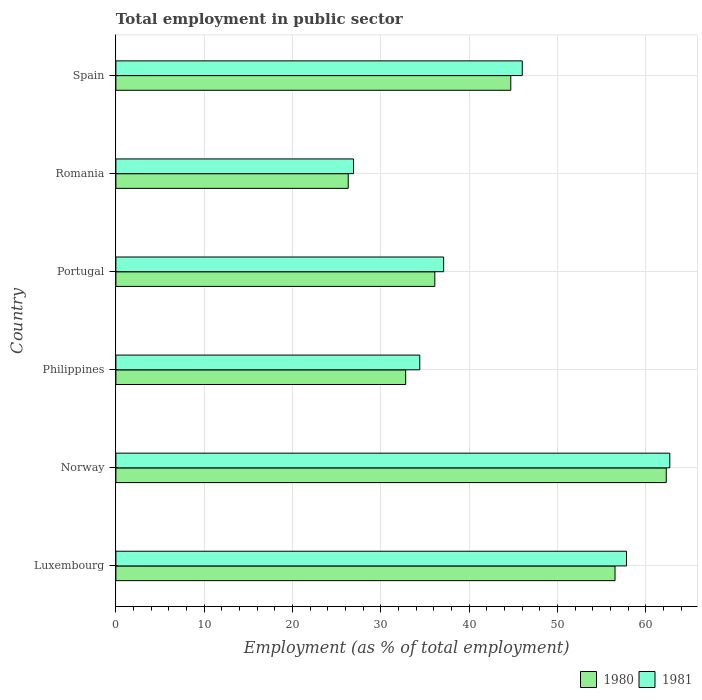How many different coloured bars are there?
Make the answer very short. 2. What is the label of the 1st group of bars from the top?
Offer a very short reply. Spain. What is the employment in public sector in 1980 in Philippines?
Provide a short and direct response. 32.8. Across all countries, what is the maximum employment in public sector in 1980?
Provide a short and direct response. 62.3. Across all countries, what is the minimum employment in public sector in 1981?
Make the answer very short. 26.9. In which country was the employment in public sector in 1980 minimum?
Offer a very short reply. Romania. What is the total employment in public sector in 1981 in the graph?
Your answer should be very brief. 264.9. What is the difference between the employment in public sector in 1981 in Portugal and that in Romania?
Your response must be concise. 10.2. What is the difference between the employment in public sector in 1980 in Romania and the employment in public sector in 1981 in Norway?
Offer a very short reply. -36.4. What is the average employment in public sector in 1981 per country?
Your answer should be very brief. 44.15. What is the difference between the employment in public sector in 1980 and employment in public sector in 1981 in Norway?
Keep it short and to the point. -0.4. What is the ratio of the employment in public sector in 1981 in Norway to that in Portugal?
Your answer should be very brief. 1.69. Is the difference between the employment in public sector in 1980 in Romania and Spain greater than the difference between the employment in public sector in 1981 in Romania and Spain?
Offer a terse response. Yes. What is the difference between the highest and the second highest employment in public sector in 1981?
Give a very brief answer. 4.9. In how many countries, is the employment in public sector in 1980 greater than the average employment in public sector in 1980 taken over all countries?
Keep it short and to the point. 3. What does the 2nd bar from the top in Philippines represents?
Give a very brief answer. 1980. What does the 2nd bar from the bottom in Luxembourg represents?
Your response must be concise. 1981. Are the values on the major ticks of X-axis written in scientific E-notation?
Your answer should be very brief. No. Where does the legend appear in the graph?
Ensure brevity in your answer.  Bottom right. How many legend labels are there?
Provide a short and direct response. 2. How are the legend labels stacked?
Ensure brevity in your answer.  Horizontal. What is the title of the graph?
Your answer should be compact. Total employment in public sector. Does "2015" appear as one of the legend labels in the graph?
Offer a terse response. No. What is the label or title of the X-axis?
Your answer should be very brief. Employment (as % of total employment). What is the label or title of the Y-axis?
Offer a terse response. Country. What is the Employment (as % of total employment) in 1980 in Luxembourg?
Offer a very short reply. 56.5. What is the Employment (as % of total employment) in 1981 in Luxembourg?
Your response must be concise. 57.8. What is the Employment (as % of total employment) in 1980 in Norway?
Your answer should be very brief. 62.3. What is the Employment (as % of total employment) of 1981 in Norway?
Keep it short and to the point. 62.7. What is the Employment (as % of total employment) of 1980 in Philippines?
Give a very brief answer. 32.8. What is the Employment (as % of total employment) in 1981 in Philippines?
Offer a terse response. 34.4. What is the Employment (as % of total employment) of 1980 in Portugal?
Your response must be concise. 36.1. What is the Employment (as % of total employment) of 1981 in Portugal?
Make the answer very short. 37.1. What is the Employment (as % of total employment) of 1980 in Romania?
Provide a short and direct response. 26.3. What is the Employment (as % of total employment) in 1981 in Romania?
Keep it short and to the point. 26.9. What is the Employment (as % of total employment) in 1980 in Spain?
Offer a terse response. 44.7. What is the Employment (as % of total employment) in 1981 in Spain?
Keep it short and to the point. 46. Across all countries, what is the maximum Employment (as % of total employment) in 1980?
Your answer should be compact. 62.3. Across all countries, what is the maximum Employment (as % of total employment) in 1981?
Keep it short and to the point. 62.7. Across all countries, what is the minimum Employment (as % of total employment) of 1980?
Offer a terse response. 26.3. Across all countries, what is the minimum Employment (as % of total employment) of 1981?
Make the answer very short. 26.9. What is the total Employment (as % of total employment) in 1980 in the graph?
Provide a succinct answer. 258.7. What is the total Employment (as % of total employment) in 1981 in the graph?
Your response must be concise. 264.9. What is the difference between the Employment (as % of total employment) of 1981 in Luxembourg and that in Norway?
Ensure brevity in your answer.  -4.9. What is the difference between the Employment (as % of total employment) in 1980 in Luxembourg and that in Philippines?
Offer a very short reply. 23.7. What is the difference between the Employment (as % of total employment) in 1981 in Luxembourg and that in Philippines?
Make the answer very short. 23.4. What is the difference between the Employment (as % of total employment) of 1980 in Luxembourg and that in Portugal?
Keep it short and to the point. 20.4. What is the difference between the Employment (as % of total employment) of 1981 in Luxembourg and that in Portugal?
Keep it short and to the point. 20.7. What is the difference between the Employment (as % of total employment) in 1980 in Luxembourg and that in Romania?
Ensure brevity in your answer.  30.2. What is the difference between the Employment (as % of total employment) in 1981 in Luxembourg and that in Romania?
Provide a short and direct response. 30.9. What is the difference between the Employment (as % of total employment) of 1980 in Luxembourg and that in Spain?
Make the answer very short. 11.8. What is the difference between the Employment (as % of total employment) in 1980 in Norway and that in Philippines?
Your answer should be very brief. 29.5. What is the difference between the Employment (as % of total employment) of 1981 in Norway and that in Philippines?
Offer a terse response. 28.3. What is the difference between the Employment (as % of total employment) of 1980 in Norway and that in Portugal?
Your answer should be very brief. 26.2. What is the difference between the Employment (as % of total employment) in 1981 in Norway and that in Portugal?
Your answer should be compact. 25.6. What is the difference between the Employment (as % of total employment) in 1981 in Norway and that in Romania?
Your answer should be very brief. 35.8. What is the difference between the Employment (as % of total employment) of 1981 in Norway and that in Spain?
Make the answer very short. 16.7. What is the difference between the Employment (as % of total employment) of 1981 in Philippines and that in Portugal?
Keep it short and to the point. -2.7. What is the difference between the Employment (as % of total employment) of 1980 in Philippines and that in Spain?
Provide a succinct answer. -11.9. What is the difference between the Employment (as % of total employment) of 1981 in Philippines and that in Spain?
Offer a terse response. -11.6. What is the difference between the Employment (as % of total employment) of 1980 in Portugal and that in Romania?
Ensure brevity in your answer.  9.8. What is the difference between the Employment (as % of total employment) in 1981 in Portugal and that in Romania?
Ensure brevity in your answer.  10.2. What is the difference between the Employment (as % of total employment) of 1980 in Romania and that in Spain?
Offer a very short reply. -18.4. What is the difference between the Employment (as % of total employment) of 1981 in Romania and that in Spain?
Your answer should be very brief. -19.1. What is the difference between the Employment (as % of total employment) in 1980 in Luxembourg and the Employment (as % of total employment) in 1981 in Philippines?
Provide a short and direct response. 22.1. What is the difference between the Employment (as % of total employment) in 1980 in Luxembourg and the Employment (as % of total employment) in 1981 in Portugal?
Your answer should be compact. 19.4. What is the difference between the Employment (as % of total employment) of 1980 in Luxembourg and the Employment (as % of total employment) of 1981 in Romania?
Provide a short and direct response. 29.6. What is the difference between the Employment (as % of total employment) of 1980 in Luxembourg and the Employment (as % of total employment) of 1981 in Spain?
Your answer should be compact. 10.5. What is the difference between the Employment (as % of total employment) in 1980 in Norway and the Employment (as % of total employment) in 1981 in Philippines?
Your response must be concise. 27.9. What is the difference between the Employment (as % of total employment) of 1980 in Norway and the Employment (as % of total employment) of 1981 in Portugal?
Your answer should be very brief. 25.2. What is the difference between the Employment (as % of total employment) in 1980 in Norway and the Employment (as % of total employment) in 1981 in Romania?
Your answer should be compact. 35.4. What is the difference between the Employment (as % of total employment) in 1980 in Norway and the Employment (as % of total employment) in 1981 in Spain?
Your answer should be very brief. 16.3. What is the difference between the Employment (as % of total employment) in 1980 in Philippines and the Employment (as % of total employment) in 1981 in Portugal?
Provide a short and direct response. -4.3. What is the difference between the Employment (as % of total employment) of 1980 in Portugal and the Employment (as % of total employment) of 1981 in Spain?
Your answer should be very brief. -9.9. What is the difference between the Employment (as % of total employment) of 1980 in Romania and the Employment (as % of total employment) of 1981 in Spain?
Your answer should be compact. -19.7. What is the average Employment (as % of total employment) of 1980 per country?
Offer a very short reply. 43.12. What is the average Employment (as % of total employment) of 1981 per country?
Keep it short and to the point. 44.15. What is the difference between the Employment (as % of total employment) in 1980 and Employment (as % of total employment) in 1981 in Luxembourg?
Offer a very short reply. -1.3. What is the difference between the Employment (as % of total employment) in 1980 and Employment (as % of total employment) in 1981 in Norway?
Keep it short and to the point. -0.4. What is the difference between the Employment (as % of total employment) in 1980 and Employment (as % of total employment) in 1981 in Philippines?
Your answer should be compact. -1.6. What is the difference between the Employment (as % of total employment) of 1980 and Employment (as % of total employment) of 1981 in Portugal?
Ensure brevity in your answer.  -1. What is the difference between the Employment (as % of total employment) in 1980 and Employment (as % of total employment) in 1981 in Romania?
Make the answer very short. -0.6. What is the ratio of the Employment (as % of total employment) in 1980 in Luxembourg to that in Norway?
Offer a very short reply. 0.91. What is the ratio of the Employment (as % of total employment) of 1981 in Luxembourg to that in Norway?
Your answer should be compact. 0.92. What is the ratio of the Employment (as % of total employment) of 1980 in Luxembourg to that in Philippines?
Provide a succinct answer. 1.72. What is the ratio of the Employment (as % of total employment) in 1981 in Luxembourg to that in Philippines?
Your answer should be compact. 1.68. What is the ratio of the Employment (as % of total employment) of 1980 in Luxembourg to that in Portugal?
Offer a terse response. 1.57. What is the ratio of the Employment (as % of total employment) of 1981 in Luxembourg to that in Portugal?
Provide a short and direct response. 1.56. What is the ratio of the Employment (as % of total employment) of 1980 in Luxembourg to that in Romania?
Your response must be concise. 2.15. What is the ratio of the Employment (as % of total employment) in 1981 in Luxembourg to that in Romania?
Your response must be concise. 2.15. What is the ratio of the Employment (as % of total employment) of 1980 in Luxembourg to that in Spain?
Provide a short and direct response. 1.26. What is the ratio of the Employment (as % of total employment) of 1981 in Luxembourg to that in Spain?
Provide a short and direct response. 1.26. What is the ratio of the Employment (as % of total employment) in 1980 in Norway to that in Philippines?
Offer a very short reply. 1.9. What is the ratio of the Employment (as % of total employment) of 1981 in Norway to that in Philippines?
Offer a terse response. 1.82. What is the ratio of the Employment (as % of total employment) in 1980 in Norway to that in Portugal?
Your answer should be compact. 1.73. What is the ratio of the Employment (as % of total employment) in 1981 in Norway to that in Portugal?
Offer a terse response. 1.69. What is the ratio of the Employment (as % of total employment) in 1980 in Norway to that in Romania?
Keep it short and to the point. 2.37. What is the ratio of the Employment (as % of total employment) in 1981 in Norway to that in Romania?
Offer a very short reply. 2.33. What is the ratio of the Employment (as % of total employment) of 1980 in Norway to that in Spain?
Offer a terse response. 1.39. What is the ratio of the Employment (as % of total employment) of 1981 in Norway to that in Spain?
Provide a short and direct response. 1.36. What is the ratio of the Employment (as % of total employment) in 1980 in Philippines to that in Portugal?
Offer a very short reply. 0.91. What is the ratio of the Employment (as % of total employment) of 1981 in Philippines to that in Portugal?
Your response must be concise. 0.93. What is the ratio of the Employment (as % of total employment) of 1980 in Philippines to that in Romania?
Provide a succinct answer. 1.25. What is the ratio of the Employment (as % of total employment) in 1981 in Philippines to that in Romania?
Give a very brief answer. 1.28. What is the ratio of the Employment (as % of total employment) in 1980 in Philippines to that in Spain?
Keep it short and to the point. 0.73. What is the ratio of the Employment (as % of total employment) in 1981 in Philippines to that in Spain?
Offer a very short reply. 0.75. What is the ratio of the Employment (as % of total employment) in 1980 in Portugal to that in Romania?
Make the answer very short. 1.37. What is the ratio of the Employment (as % of total employment) in 1981 in Portugal to that in Romania?
Ensure brevity in your answer.  1.38. What is the ratio of the Employment (as % of total employment) of 1980 in Portugal to that in Spain?
Keep it short and to the point. 0.81. What is the ratio of the Employment (as % of total employment) of 1981 in Portugal to that in Spain?
Make the answer very short. 0.81. What is the ratio of the Employment (as % of total employment) in 1980 in Romania to that in Spain?
Your answer should be compact. 0.59. What is the ratio of the Employment (as % of total employment) in 1981 in Romania to that in Spain?
Your answer should be very brief. 0.58. What is the difference between the highest and the second highest Employment (as % of total employment) in 1980?
Ensure brevity in your answer.  5.8. What is the difference between the highest and the second highest Employment (as % of total employment) in 1981?
Offer a very short reply. 4.9. What is the difference between the highest and the lowest Employment (as % of total employment) of 1980?
Provide a short and direct response. 36. What is the difference between the highest and the lowest Employment (as % of total employment) of 1981?
Provide a succinct answer. 35.8. 